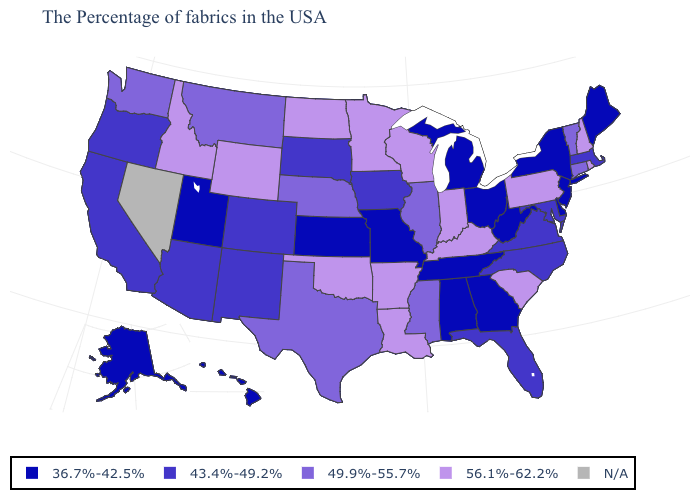Among the states that border Mississippi , which have the highest value?
Give a very brief answer. Louisiana, Arkansas. How many symbols are there in the legend?
Answer briefly. 5. What is the lowest value in the Northeast?
Short answer required. 36.7%-42.5%. Is the legend a continuous bar?
Keep it brief. No. Name the states that have a value in the range N/A?
Write a very short answer. Nevada. What is the value of New Jersey?
Be succinct. 36.7%-42.5%. Which states have the highest value in the USA?
Write a very short answer. Rhode Island, New Hampshire, Pennsylvania, South Carolina, Kentucky, Indiana, Wisconsin, Louisiana, Arkansas, Minnesota, Oklahoma, North Dakota, Wyoming, Idaho. How many symbols are there in the legend?
Give a very brief answer. 5. What is the value of South Carolina?
Keep it brief. 56.1%-62.2%. Which states have the lowest value in the Northeast?
Keep it brief. Maine, New York, New Jersey. Does Alaska have the highest value in the West?
Concise answer only. No. Among the states that border Indiana , which have the highest value?
Write a very short answer. Kentucky. Name the states that have a value in the range 43.4%-49.2%?
Quick response, please. Massachusetts, Maryland, Virginia, North Carolina, Florida, Iowa, South Dakota, Colorado, New Mexico, Arizona, California, Oregon. Which states have the highest value in the USA?
Give a very brief answer. Rhode Island, New Hampshire, Pennsylvania, South Carolina, Kentucky, Indiana, Wisconsin, Louisiana, Arkansas, Minnesota, Oklahoma, North Dakota, Wyoming, Idaho. 